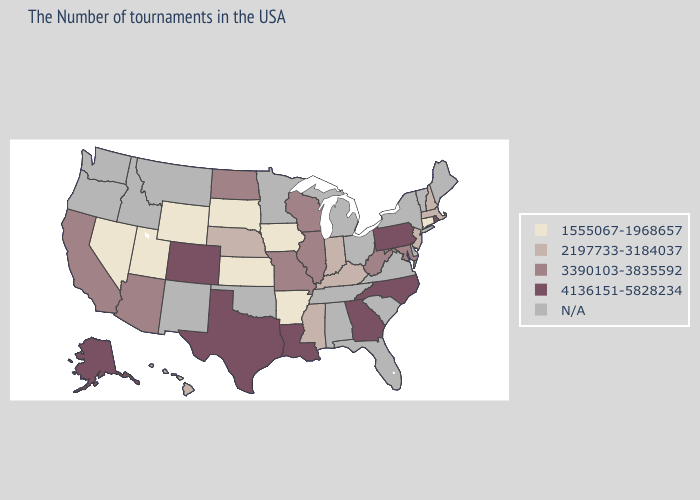What is the value of Arizona?
Keep it brief. 3390103-3835592. Does North Dakota have the lowest value in the USA?
Concise answer only. No. Which states have the lowest value in the MidWest?
Answer briefly. Iowa, Kansas, South Dakota. What is the highest value in states that border Colorado?
Concise answer only. 3390103-3835592. Does Utah have the lowest value in the USA?
Be succinct. Yes. Does the first symbol in the legend represent the smallest category?
Answer briefly. Yes. Does the first symbol in the legend represent the smallest category?
Be succinct. Yes. Among the states that border Connecticut , does Rhode Island have the highest value?
Keep it brief. Yes. How many symbols are there in the legend?
Answer briefly. 5. Name the states that have a value in the range N/A?
Quick response, please. Maine, Vermont, New York, Delaware, Virginia, South Carolina, Ohio, Florida, Michigan, Alabama, Tennessee, Minnesota, Oklahoma, New Mexico, Montana, Idaho, Washington, Oregon. Among the states that border Georgia , which have the highest value?
Quick response, please. North Carolina. What is the value of Wyoming?
Keep it brief. 1555067-1968657. 